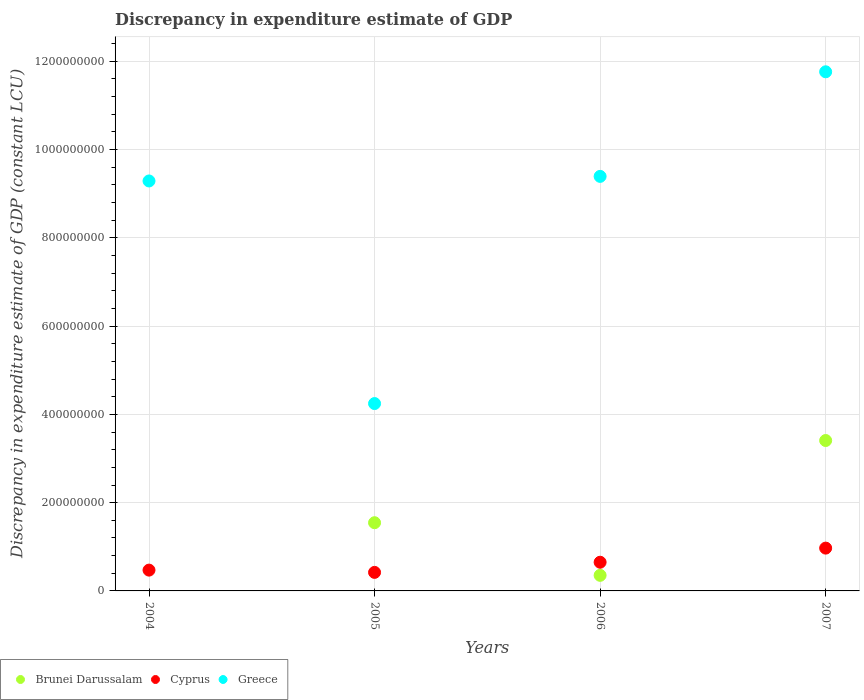How many different coloured dotlines are there?
Your response must be concise. 3. Is the number of dotlines equal to the number of legend labels?
Give a very brief answer. No. What is the discrepancy in expenditure estimate of GDP in Greece in 2004?
Offer a terse response. 9.29e+08. Across all years, what is the maximum discrepancy in expenditure estimate of GDP in Cyprus?
Ensure brevity in your answer.  9.70e+07. What is the total discrepancy in expenditure estimate of GDP in Greece in the graph?
Keep it short and to the point. 3.47e+09. What is the difference between the discrepancy in expenditure estimate of GDP in Cyprus in 2005 and that in 2006?
Make the answer very short. -2.30e+07. What is the difference between the discrepancy in expenditure estimate of GDP in Brunei Darussalam in 2006 and the discrepancy in expenditure estimate of GDP in Greece in 2005?
Make the answer very short. -3.89e+08. What is the average discrepancy in expenditure estimate of GDP in Brunei Darussalam per year?
Ensure brevity in your answer.  1.33e+08. In the year 2005, what is the difference between the discrepancy in expenditure estimate of GDP in Cyprus and discrepancy in expenditure estimate of GDP in Brunei Darussalam?
Offer a terse response. -1.13e+08. In how many years, is the discrepancy in expenditure estimate of GDP in Brunei Darussalam greater than 80000000 LCU?
Ensure brevity in your answer.  2. What is the ratio of the discrepancy in expenditure estimate of GDP in Brunei Darussalam in 2005 to that in 2006?
Your response must be concise. 4.38. Is the discrepancy in expenditure estimate of GDP in Greece in 2005 less than that in 2006?
Your response must be concise. Yes. Is the difference between the discrepancy in expenditure estimate of GDP in Cyprus in 2006 and 2007 greater than the difference between the discrepancy in expenditure estimate of GDP in Brunei Darussalam in 2006 and 2007?
Offer a very short reply. Yes. What is the difference between the highest and the second highest discrepancy in expenditure estimate of GDP in Brunei Darussalam?
Provide a short and direct response. 1.86e+08. What is the difference between the highest and the lowest discrepancy in expenditure estimate of GDP in Brunei Darussalam?
Ensure brevity in your answer.  3.41e+08. In how many years, is the discrepancy in expenditure estimate of GDP in Brunei Darussalam greater than the average discrepancy in expenditure estimate of GDP in Brunei Darussalam taken over all years?
Make the answer very short. 2. Is the sum of the discrepancy in expenditure estimate of GDP in Greece in 2004 and 2007 greater than the maximum discrepancy in expenditure estimate of GDP in Brunei Darussalam across all years?
Ensure brevity in your answer.  Yes. Is it the case that in every year, the sum of the discrepancy in expenditure estimate of GDP in Cyprus and discrepancy in expenditure estimate of GDP in Greece  is greater than the discrepancy in expenditure estimate of GDP in Brunei Darussalam?
Provide a short and direct response. Yes. Is the discrepancy in expenditure estimate of GDP in Cyprus strictly greater than the discrepancy in expenditure estimate of GDP in Greece over the years?
Provide a short and direct response. No. How many dotlines are there?
Provide a short and direct response. 3. Are the values on the major ticks of Y-axis written in scientific E-notation?
Your response must be concise. No. Does the graph contain any zero values?
Your answer should be very brief. Yes. Where does the legend appear in the graph?
Offer a terse response. Bottom left. How many legend labels are there?
Ensure brevity in your answer.  3. How are the legend labels stacked?
Make the answer very short. Horizontal. What is the title of the graph?
Offer a very short reply. Discrepancy in expenditure estimate of GDP. Does "Jordan" appear as one of the legend labels in the graph?
Provide a succinct answer. No. What is the label or title of the X-axis?
Give a very brief answer. Years. What is the label or title of the Y-axis?
Offer a terse response. Discrepancy in expenditure estimate of GDP (constant LCU). What is the Discrepancy in expenditure estimate of GDP (constant LCU) of Cyprus in 2004?
Keep it short and to the point. 4.71e+07. What is the Discrepancy in expenditure estimate of GDP (constant LCU) in Greece in 2004?
Give a very brief answer. 9.29e+08. What is the Discrepancy in expenditure estimate of GDP (constant LCU) of Brunei Darussalam in 2005?
Keep it short and to the point. 1.55e+08. What is the Discrepancy in expenditure estimate of GDP (constant LCU) of Cyprus in 2005?
Your answer should be very brief. 4.20e+07. What is the Discrepancy in expenditure estimate of GDP (constant LCU) in Greece in 2005?
Offer a very short reply. 4.25e+08. What is the Discrepancy in expenditure estimate of GDP (constant LCU) in Brunei Darussalam in 2006?
Provide a succinct answer. 3.53e+07. What is the Discrepancy in expenditure estimate of GDP (constant LCU) in Cyprus in 2006?
Your response must be concise. 6.50e+07. What is the Discrepancy in expenditure estimate of GDP (constant LCU) in Greece in 2006?
Offer a very short reply. 9.39e+08. What is the Discrepancy in expenditure estimate of GDP (constant LCU) in Brunei Darussalam in 2007?
Your answer should be very brief. 3.41e+08. What is the Discrepancy in expenditure estimate of GDP (constant LCU) in Cyprus in 2007?
Ensure brevity in your answer.  9.70e+07. What is the Discrepancy in expenditure estimate of GDP (constant LCU) in Greece in 2007?
Your answer should be very brief. 1.18e+09. Across all years, what is the maximum Discrepancy in expenditure estimate of GDP (constant LCU) in Brunei Darussalam?
Ensure brevity in your answer.  3.41e+08. Across all years, what is the maximum Discrepancy in expenditure estimate of GDP (constant LCU) of Cyprus?
Keep it short and to the point. 9.70e+07. Across all years, what is the maximum Discrepancy in expenditure estimate of GDP (constant LCU) of Greece?
Ensure brevity in your answer.  1.18e+09. Across all years, what is the minimum Discrepancy in expenditure estimate of GDP (constant LCU) of Cyprus?
Provide a succinct answer. 4.20e+07. Across all years, what is the minimum Discrepancy in expenditure estimate of GDP (constant LCU) in Greece?
Give a very brief answer. 4.25e+08. What is the total Discrepancy in expenditure estimate of GDP (constant LCU) of Brunei Darussalam in the graph?
Your answer should be compact. 5.31e+08. What is the total Discrepancy in expenditure estimate of GDP (constant LCU) in Cyprus in the graph?
Your answer should be very brief. 2.51e+08. What is the total Discrepancy in expenditure estimate of GDP (constant LCU) in Greece in the graph?
Provide a succinct answer. 3.47e+09. What is the difference between the Discrepancy in expenditure estimate of GDP (constant LCU) in Cyprus in 2004 and that in 2005?
Give a very brief answer. 5.14e+06. What is the difference between the Discrepancy in expenditure estimate of GDP (constant LCU) of Greece in 2004 and that in 2005?
Your answer should be compact. 5.04e+08. What is the difference between the Discrepancy in expenditure estimate of GDP (constant LCU) of Cyprus in 2004 and that in 2006?
Your answer should be very brief. -1.79e+07. What is the difference between the Discrepancy in expenditure estimate of GDP (constant LCU) in Greece in 2004 and that in 2006?
Provide a succinct answer. -1.04e+07. What is the difference between the Discrepancy in expenditure estimate of GDP (constant LCU) in Cyprus in 2004 and that in 2007?
Make the answer very short. -4.99e+07. What is the difference between the Discrepancy in expenditure estimate of GDP (constant LCU) in Greece in 2004 and that in 2007?
Ensure brevity in your answer.  -2.47e+08. What is the difference between the Discrepancy in expenditure estimate of GDP (constant LCU) in Brunei Darussalam in 2005 and that in 2006?
Provide a succinct answer. 1.19e+08. What is the difference between the Discrepancy in expenditure estimate of GDP (constant LCU) of Cyprus in 2005 and that in 2006?
Give a very brief answer. -2.30e+07. What is the difference between the Discrepancy in expenditure estimate of GDP (constant LCU) of Greece in 2005 and that in 2006?
Your response must be concise. -5.15e+08. What is the difference between the Discrepancy in expenditure estimate of GDP (constant LCU) in Brunei Darussalam in 2005 and that in 2007?
Make the answer very short. -1.86e+08. What is the difference between the Discrepancy in expenditure estimate of GDP (constant LCU) of Cyprus in 2005 and that in 2007?
Your response must be concise. -5.50e+07. What is the difference between the Discrepancy in expenditure estimate of GDP (constant LCU) in Greece in 2005 and that in 2007?
Your answer should be compact. -7.52e+08. What is the difference between the Discrepancy in expenditure estimate of GDP (constant LCU) of Brunei Darussalam in 2006 and that in 2007?
Offer a very short reply. -3.06e+08. What is the difference between the Discrepancy in expenditure estimate of GDP (constant LCU) of Cyprus in 2006 and that in 2007?
Ensure brevity in your answer.  -3.20e+07. What is the difference between the Discrepancy in expenditure estimate of GDP (constant LCU) of Greece in 2006 and that in 2007?
Your answer should be very brief. -2.37e+08. What is the difference between the Discrepancy in expenditure estimate of GDP (constant LCU) in Cyprus in 2004 and the Discrepancy in expenditure estimate of GDP (constant LCU) in Greece in 2005?
Your response must be concise. -3.77e+08. What is the difference between the Discrepancy in expenditure estimate of GDP (constant LCU) in Cyprus in 2004 and the Discrepancy in expenditure estimate of GDP (constant LCU) in Greece in 2006?
Your response must be concise. -8.92e+08. What is the difference between the Discrepancy in expenditure estimate of GDP (constant LCU) in Cyprus in 2004 and the Discrepancy in expenditure estimate of GDP (constant LCU) in Greece in 2007?
Your answer should be very brief. -1.13e+09. What is the difference between the Discrepancy in expenditure estimate of GDP (constant LCU) in Brunei Darussalam in 2005 and the Discrepancy in expenditure estimate of GDP (constant LCU) in Cyprus in 2006?
Give a very brief answer. 8.95e+07. What is the difference between the Discrepancy in expenditure estimate of GDP (constant LCU) in Brunei Darussalam in 2005 and the Discrepancy in expenditure estimate of GDP (constant LCU) in Greece in 2006?
Provide a succinct answer. -7.85e+08. What is the difference between the Discrepancy in expenditure estimate of GDP (constant LCU) of Cyprus in 2005 and the Discrepancy in expenditure estimate of GDP (constant LCU) of Greece in 2006?
Your response must be concise. -8.97e+08. What is the difference between the Discrepancy in expenditure estimate of GDP (constant LCU) of Brunei Darussalam in 2005 and the Discrepancy in expenditure estimate of GDP (constant LCU) of Cyprus in 2007?
Offer a very short reply. 5.75e+07. What is the difference between the Discrepancy in expenditure estimate of GDP (constant LCU) in Brunei Darussalam in 2005 and the Discrepancy in expenditure estimate of GDP (constant LCU) in Greece in 2007?
Keep it short and to the point. -1.02e+09. What is the difference between the Discrepancy in expenditure estimate of GDP (constant LCU) in Cyprus in 2005 and the Discrepancy in expenditure estimate of GDP (constant LCU) in Greece in 2007?
Keep it short and to the point. -1.13e+09. What is the difference between the Discrepancy in expenditure estimate of GDP (constant LCU) of Brunei Darussalam in 2006 and the Discrepancy in expenditure estimate of GDP (constant LCU) of Cyprus in 2007?
Provide a succinct answer. -6.17e+07. What is the difference between the Discrepancy in expenditure estimate of GDP (constant LCU) in Brunei Darussalam in 2006 and the Discrepancy in expenditure estimate of GDP (constant LCU) in Greece in 2007?
Offer a very short reply. -1.14e+09. What is the difference between the Discrepancy in expenditure estimate of GDP (constant LCU) of Cyprus in 2006 and the Discrepancy in expenditure estimate of GDP (constant LCU) of Greece in 2007?
Offer a very short reply. -1.11e+09. What is the average Discrepancy in expenditure estimate of GDP (constant LCU) of Brunei Darussalam per year?
Provide a succinct answer. 1.33e+08. What is the average Discrepancy in expenditure estimate of GDP (constant LCU) in Cyprus per year?
Your answer should be compact. 6.28e+07. What is the average Discrepancy in expenditure estimate of GDP (constant LCU) in Greece per year?
Provide a succinct answer. 8.67e+08. In the year 2004, what is the difference between the Discrepancy in expenditure estimate of GDP (constant LCU) of Cyprus and Discrepancy in expenditure estimate of GDP (constant LCU) of Greece?
Provide a succinct answer. -8.82e+08. In the year 2005, what is the difference between the Discrepancy in expenditure estimate of GDP (constant LCU) of Brunei Darussalam and Discrepancy in expenditure estimate of GDP (constant LCU) of Cyprus?
Provide a succinct answer. 1.13e+08. In the year 2005, what is the difference between the Discrepancy in expenditure estimate of GDP (constant LCU) in Brunei Darussalam and Discrepancy in expenditure estimate of GDP (constant LCU) in Greece?
Provide a short and direct response. -2.70e+08. In the year 2005, what is the difference between the Discrepancy in expenditure estimate of GDP (constant LCU) in Cyprus and Discrepancy in expenditure estimate of GDP (constant LCU) in Greece?
Offer a very short reply. -3.83e+08. In the year 2006, what is the difference between the Discrepancy in expenditure estimate of GDP (constant LCU) of Brunei Darussalam and Discrepancy in expenditure estimate of GDP (constant LCU) of Cyprus?
Provide a succinct answer. -2.97e+07. In the year 2006, what is the difference between the Discrepancy in expenditure estimate of GDP (constant LCU) of Brunei Darussalam and Discrepancy in expenditure estimate of GDP (constant LCU) of Greece?
Offer a terse response. -9.04e+08. In the year 2006, what is the difference between the Discrepancy in expenditure estimate of GDP (constant LCU) of Cyprus and Discrepancy in expenditure estimate of GDP (constant LCU) of Greece?
Your answer should be very brief. -8.74e+08. In the year 2007, what is the difference between the Discrepancy in expenditure estimate of GDP (constant LCU) of Brunei Darussalam and Discrepancy in expenditure estimate of GDP (constant LCU) of Cyprus?
Ensure brevity in your answer.  2.44e+08. In the year 2007, what is the difference between the Discrepancy in expenditure estimate of GDP (constant LCU) in Brunei Darussalam and Discrepancy in expenditure estimate of GDP (constant LCU) in Greece?
Your response must be concise. -8.35e+08. In the year 2007, what is the difference between the Discrepancy in expenditure estimate of GDP (constant LCU) of Cyprus and Discrepancy in expenditure estimate of GDP (constant LCU) of Greece?
Provide a short and direct response. -1.08e+09. What is the ratio of the Discrepancy in expenditure estimate of GDP (constant LCU) of Cyprus in 2004 to that in 2005?
Offer a very short reply. 1.12. What is the ratio of the Discrepancy in expenditure estimate of GDP (constant LCU) in Greece in 2004 to that in 2005?
Your answer should be very brief. 2.19. What is the ratio of the Discrepancy in expenditure estimate of GDP (constant LCU) in Cyprus in 2004 to that in 2006?
Your answer should be very brief. 0.73. What is the ratio of the Discrepancy in expenditure estimate of GDP (constant LCU) of Cyprus in 2004 to that in 2007?
Keep it short and to the point. 0.49. What is the ratio of the Discrepancy in expenditure estimate of GDP (constant LCU) in Greece in 2004 to that in 2007?
Ensure brevity in your answer.  0.79. What is the ratio of the Discrepancy in expenditure estimate of GDP (constant LCU) of Brunei Darussalam in 2005 to that in 2006?
Your response must be concise. 4.38. What is the ratio of the Discrepancy in expenditure estimate of GDP (constant LCU) in Cyprus in 2005 to that in 2006?
Provide a short and direct response. 0.65. What is the ratio of the Discrepancy in expenditure estimate of GDP (constant LCU) of Greece in 2005 to that in 2006?
Offer a terse response. 0.45. What is the ratio of the Discrepancy in expenditure estimate of GDP (constant LCU) of Brunei Darussalam in 2005 to that in 2007?
Ensure brevity in your answer.  0.45. What is the ratio of the Discrepancy in expenditure estimate of GDP (constant LCU) in Cyprus in 2005 to that in 2007?
Keep it short and to the point. 0.43. What is the ratio of the Discrepancy in expenditure estimate of GDP (constant LCU) of Greece in 2005 to that in 2007?
Give a very brief answer. 0.36. What is the ratio of the Discrepancy in expenditure estimate of GDP (constant LCU) of Brunei Darussalam in 2006 to that in 2007?
Offer a terse response. 0.1. What is the ratio of the Discrepancy in expenditure estimate of GDP (constant LCU) in Cyprus in 2006 to that in 2007?
Offer a terse response. 0.67. What is the ratio of the Discrepancy in expenditure estimate of GDP (constant LCU) in Greece in 2006 to that in 2007?
Provide a short and direct response. 0.8. What is the difference between the highest and the second highest Discrepancy in expenditure estimate of GDP (constant LCU) in Brunei Darussalam?
Your answer should be compact. 1.86e+08. What is the difference between the highest and the second highest Discrepancy in expenditure estimate of GDP (constant LCU) in Cyprus?
Keep it short and to the point. 3.20e+07. What is the difference between the highest and the second highest Discrepancy in expenditure estimate of GDP (constant LCU) of Greece?
Give a very brief answer. 2.37e+08. What is the difference between the highest and the lowest Discrepancy in expenditure estimate of GDP (constant LCU) in Brunei Darussalam?
Offer a terse response. 3.41e+08. What is the difference between the highest and the lowest Discrepancy in expenditure estimate of GDP (constant LCU) in Cyprus?
Your answer should be compact. 5.50e+07. What is the difference between the highest and the lowest Discrepancy in expenditure estimate of GDP (constant LCU) in Greece?
Your answer should be very brief. 7.52e+08. 